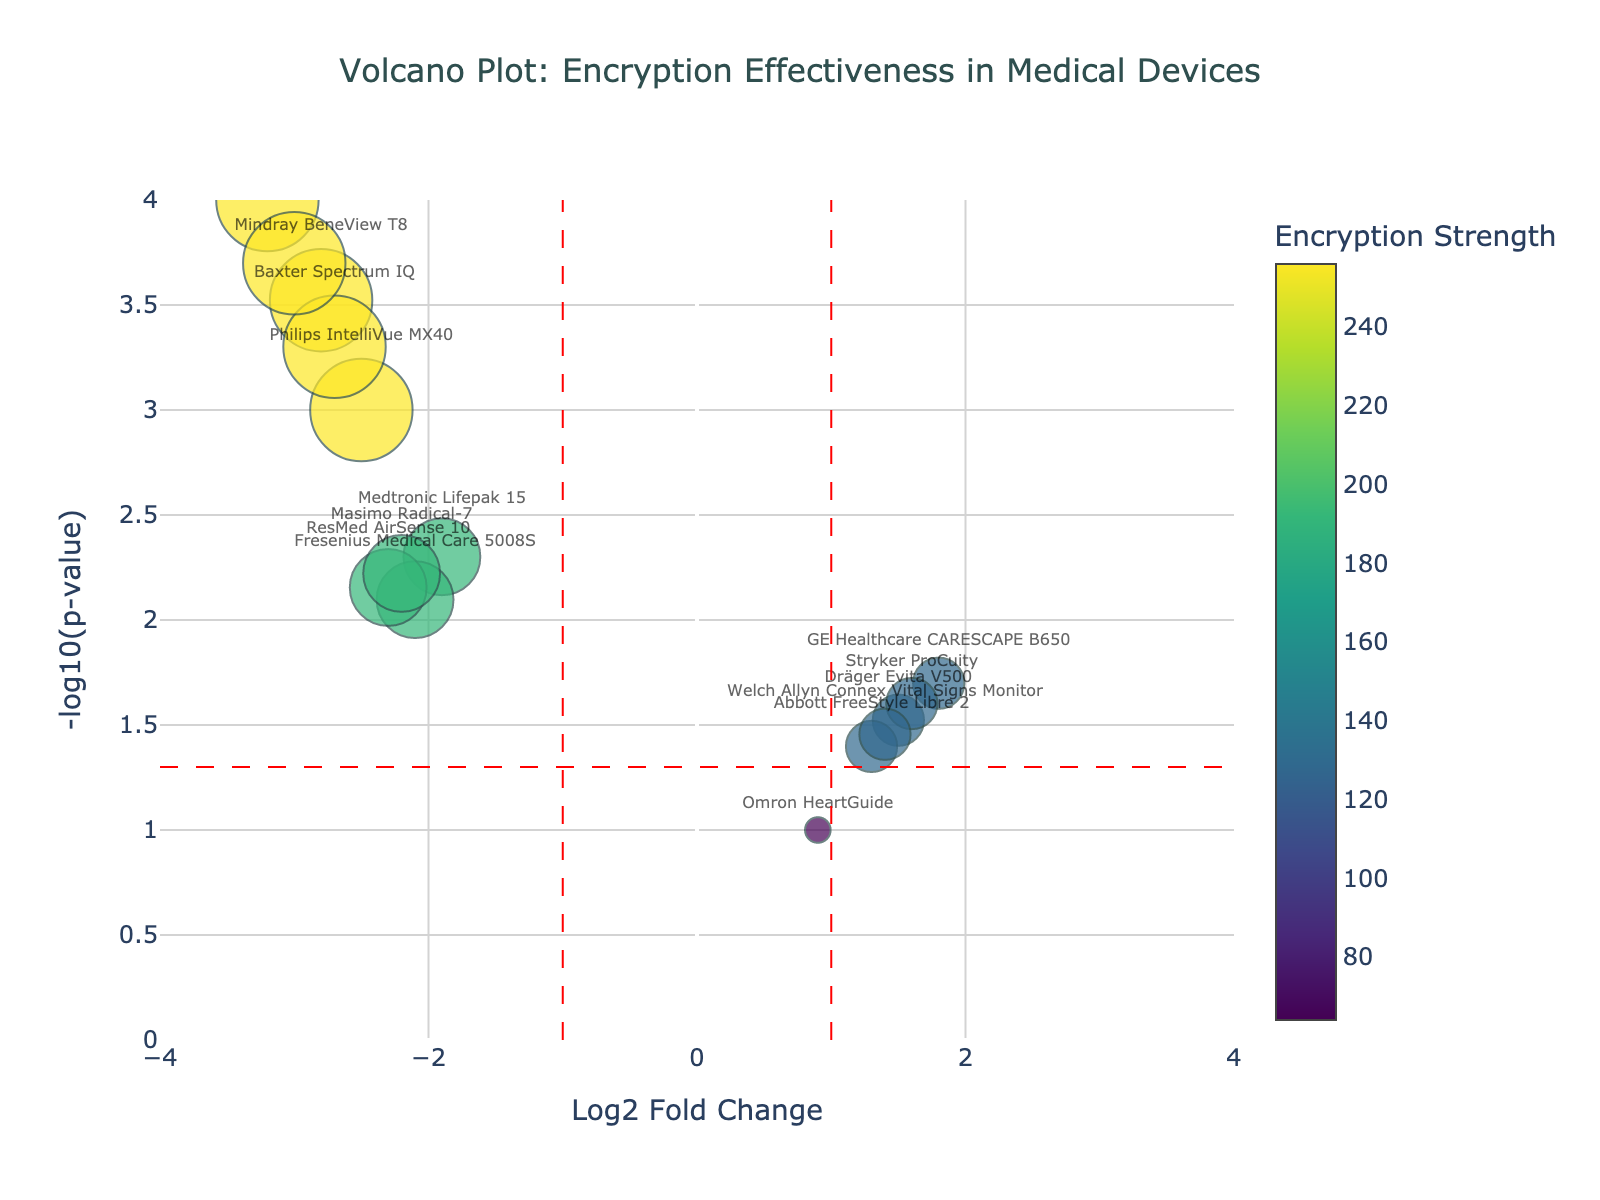What is the title of the plot? The title of the plot is located at the top center of the figure, displayed in larger font size to stand out.
Answer: Volcano Plot: Encryption Effectiveness in Medical Devices What is on the x-axis of the plot? The x-axis is labeled at the bottom of the graph and represents the "Log2 Fold Change" values in the data.
Answer: Log2 Fold Change What is on the y-axis of the plot? The y-axis is labeled on the left side of the graph and represents the "-log10(p-value)" values in the data.
Answer: -log10(p-value) How many device models have a p-value less than 0.01? Observing the y-axis, identify the points with -log10(p-value) greater than 2, corresponding to p-values less than 0.01.
Answer: 9 Which device model shows the highest encryption strength? By examining the color intensity of the markers and their corresponding hover texts, identify the model with the highest color bar value.
Answer: Philips IntelliVue MX40, Siemens Healthineers ACUSON Sequoia Which device models are considered significant outliers based on Log2 Fold Change > 1 and p-value < 0.05? Outliers are on the plot right of the red dashed line (Log2 Fold Change > 1) and above the dashed line (p-value < 0.05). These are GE Healthcare CARESCAPE B650 and Stryker ProCuity.
Answer: GE Healthcare CARESCAPE B650, Stryker ProCuity What is the Log2 Fold Change for the Mindray BeneView T8? Locate the Mindray BeneView T8 on the plot and check its position on the x-axis.
Answer: -2.8 Which model has the smallest -log10(p-value)? Find the data point closest to the y-axis origin (0) on the y-axis, indicated with the marker below others.
Answer: Omron HeartGuide Compare the encryption strengths of Medtronic Lifepak 15 and BD Alaris System. From the hover texts, Medtronic Lifepak 15 has an encryption strength of 192, while BD Alaris System has 256. BD Alaris System has a higher value.
Answer: BD Alaris System How many devices are there in the plot using 128-bit encryption? Count all data points shown in the hover texts using 128-bit encryption.
Answer: 5 